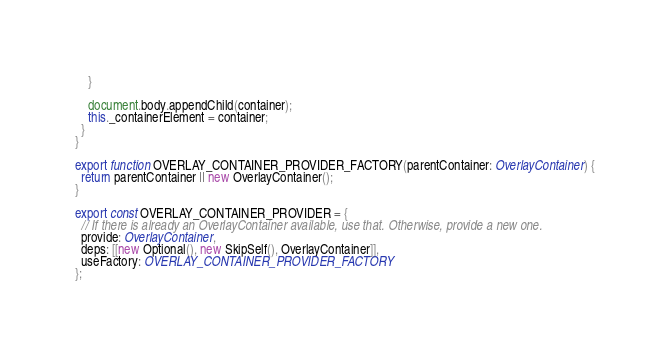Convert code to text. <code><loc_0><loc_0><loc_500><loc_500><_TypeScript_>    }

    document.body.appendChild(container);
    this._containerElement = container;
  }
}

export function OVERLAY_CONTAINER_PROVIDER_FACTORY(parentContainer: OverlayContainer) {
  return parentContainer || new OverlayContainer();
}

export const OVERLAY_CONTAINER_PROVIDER = {
  // If there is already an OverlayContainer available, use that. Otherwise, provide a new one.
  provide: OverlayContainer,
  deps: [[new Optional(), new SkipSelf(), OverlayContainer]],
  useFactory: OVERLAY_CONTAINER_PROVIDER_FACTORY
};
</code> 